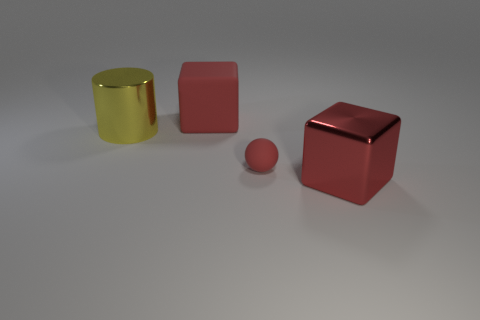There is a red metallic thing that is the same size as the cylinder; what is its shape?
Your answer should be very brief. Cube. There is another thing that is the same shape as the big red metallic object; what material is it?
Make the answer very short. Rubber. What color is the tiny rubber thing?
Provide a succinct answer. Red. How many things are either gray matte balls or blocks?
Provide a short and direct response. 2. The large thing that is to the right of the big block behind the tiny red object is what shape?
Your answer should be compact. Cube. How many other objects are the same material as the big yellow thing?
Offer a terse response. 1. Is the material of the small sphere the same as the big cube in front of the yellow shiny cylinder?
Ensure brevity in your answer.  No. What number of things are blocks that are in front of the yellow metallic cylinder or blocks on the right side of the big red matte object?
Offer a very short reply. 1. What number of other objects are the same color as the large matte object?
Offer a very short reply. 2. Are there more big red metal blocks behind the yellow cylinder than big things that are to the left of the red matte block?
Offer a very short reply. No. 